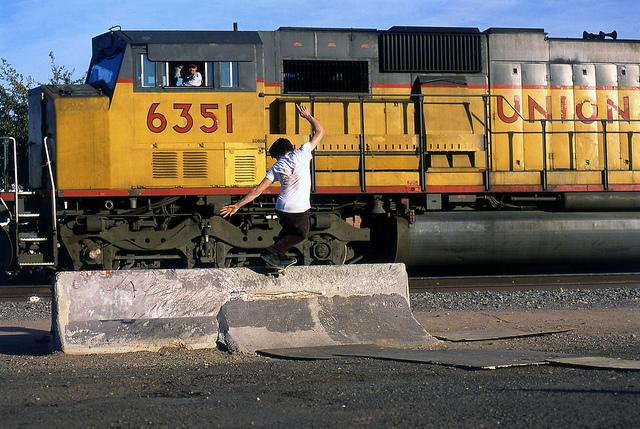Which direction did the skater just come from?

Choices:
A) train track
B) train top
C) down
D) high up down 